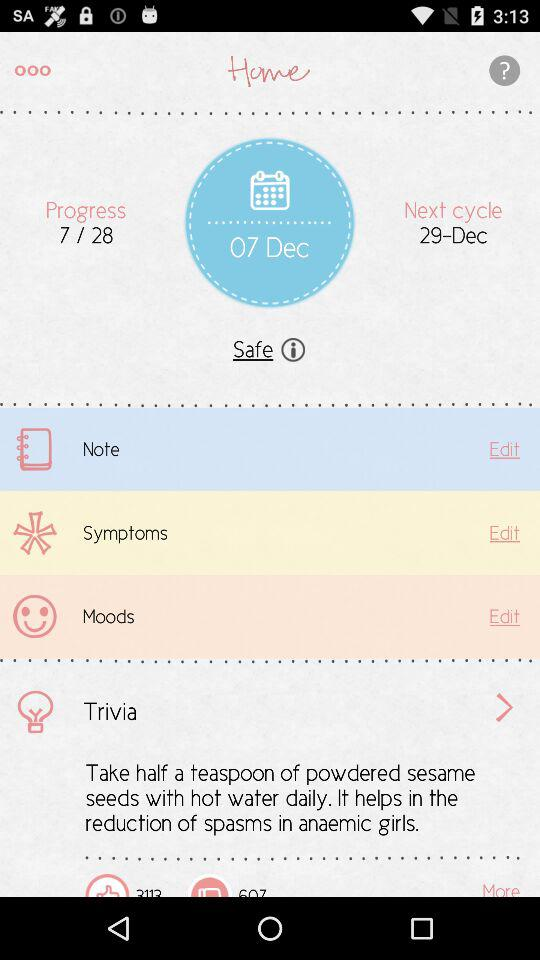What is the progress? The progress is 7/28. 